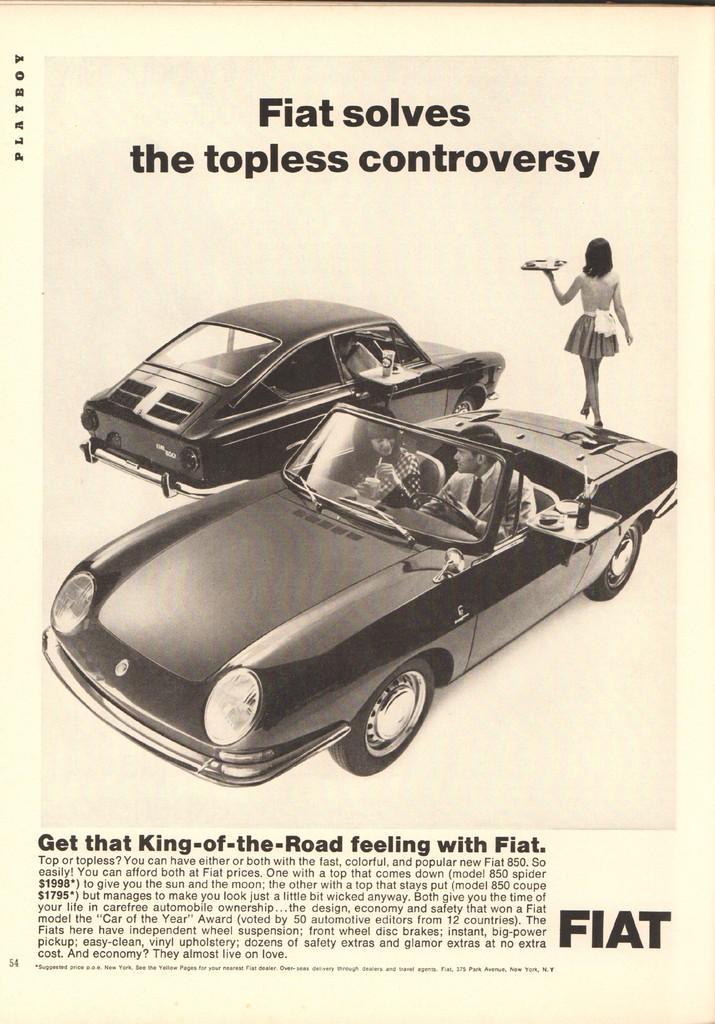Could you give a brief overview of what you see in this image? In this image we can see an advertisement. In the center there are cars and there are people in the cars. At the top and bottom we can see text. 